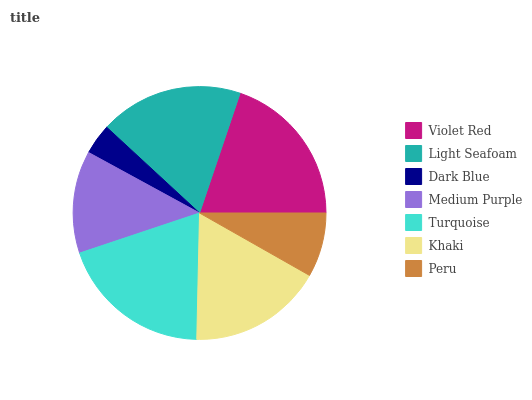Is Dark Blue the minimum?
Answer yes or no. Yes. Is Violet Red the maximum?
Answer yes or no. Yes. Is Light Seafoam the minimum?
Answer yes or no. No. Is Light Seafoam the maximum?
Answer yes or no. No. Is Violet Red greater than Light Seafoam?
Answer yes or no. Yes. Is Light Seafoam less than Violet Red?
Answer yes or no. Yes. Is Light Seafoam greater than Violet Red?
Answer yes or no. No. Is Violet Red less than Light Seafoam?
Answer yes or no. No. Is Khaki the high median?
Answer yes or no. Yes. Is Khaki the low median?
Answer yes or no. Yes. Is Turquoise the high median?
Answer yes or no. No. Is Turquoise the low median?
Answer yes or no. No. 